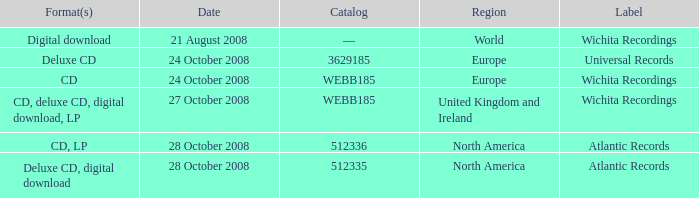Which region is associated with the catalog value of 512335? North America. 